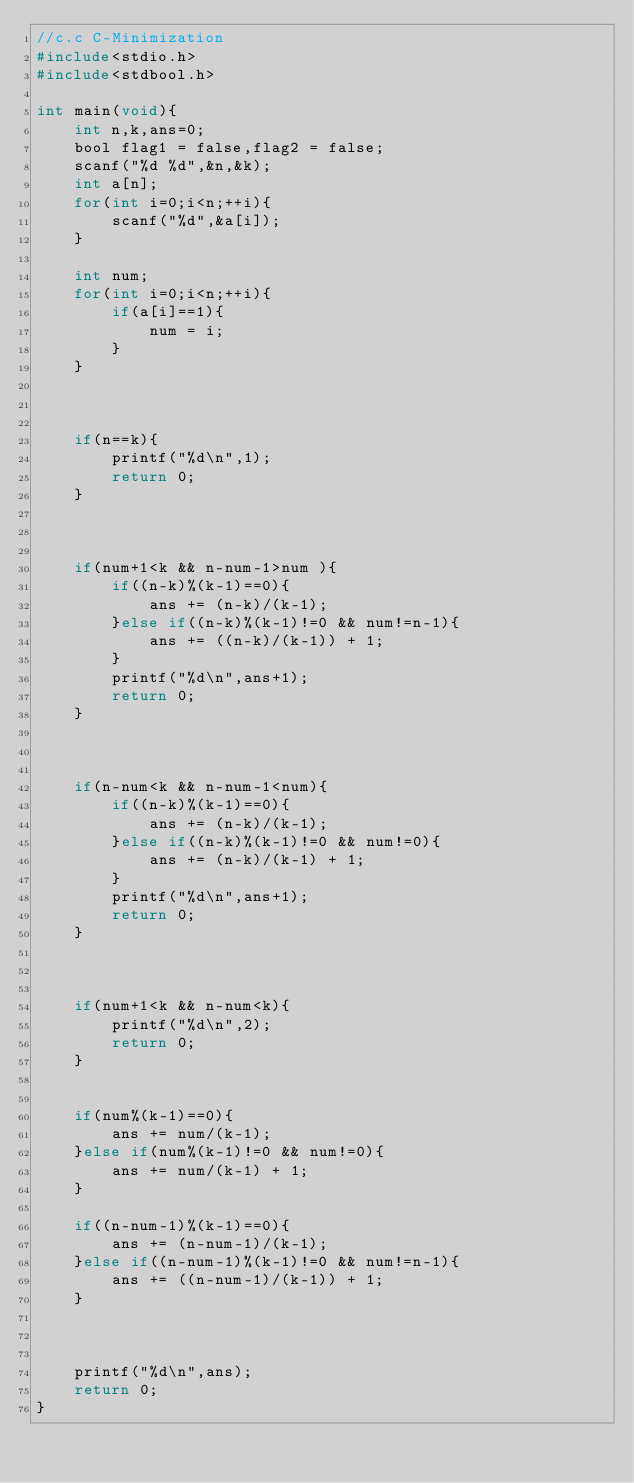<code> <loc_0><loc_0><loc_500><loc_500><_C_>//c.c C-Minimization
#include<stdio.h>
#include<stdbool.h>

int main(void){
    int n,k,ans=0;
    bool flag1 = false,flag2 = false;
    scanf("%d %d",&n,&k);
    int a[n];
    for(int i=0;i<n;++i){
        scanf("%d",&a[i]);
    }

    int num;
    for(int i=0;i<n;++i){
        if(a[i]==1){
            num = i;
        }
    }

    

    if(n==k){
        printf("%d\n",1);
        return 0;
    }

    

    if(num+1<k && n-num-1>num ){
        if((n-k)%(k-1)==0){
            ans += (n-k)/(k-1);
        }else if((n-k)%(k-1)!=0 && num!=n-1){
            ans += ((n-k)/(k-1)) + 1;
        }
        printf("%d\n",ans+1);
        return 0;
    }

    

    if(n-num<k && n-num-1<num){
        if((n-k)%(k-1)==0){
            ans += (n-k)/(k-1);
        }else if((n-k)%(k-1)!=0 && num!=0){
            ans += (n-k)/(k-1) + 1;
        }
        printf("%d\n",ans+1);
        return 0;
    }

    

    if(num+1<k && n-num<k){
        printf("%d\n",2);
        return 0;
    }

    
    if(num%(k-1)==0){
        ans += num/(k-1);
    }else if(num%(k-1)!=0 && num!=0){
        ans += num/(k-1) + 1;
    }

    if((n-num-1)%(k-1)==0){
        ans += (n-num-1)/(k-1);
    }else if((n-num-1)%(k-1)!=0 && num!=n-1){
        ans += ((n-num-1)/(k-1)) + 1;
    }

    

    printf("%d\n",ans);
    return 0;
}</code> 